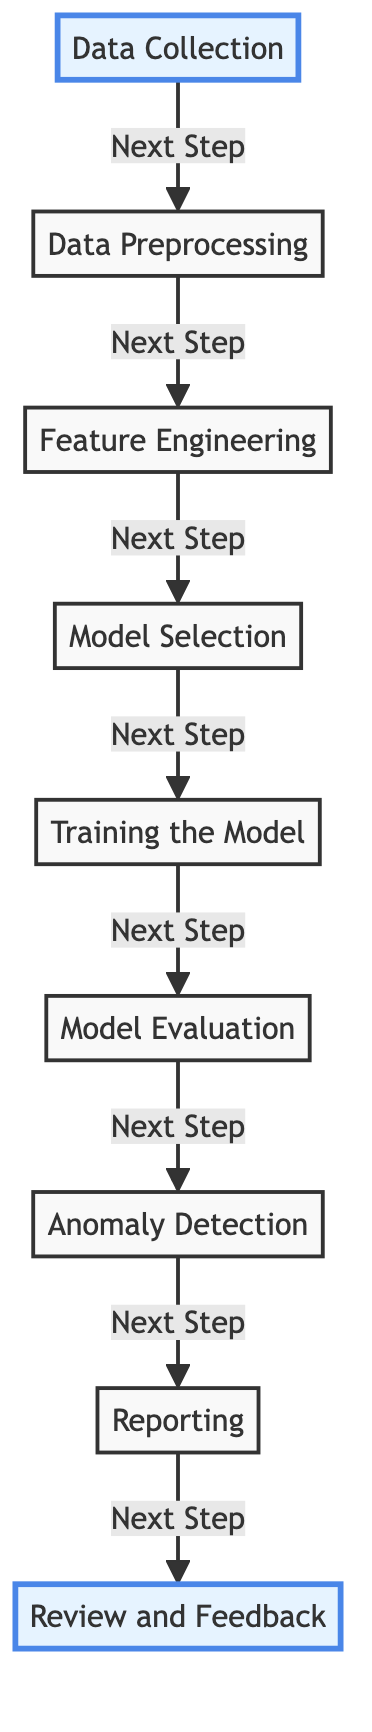What is the first step in the diagram? The first step is "Data Collection," which is indicated as the first node in the flowchart.
Answer: Data Collection How many nodes are present in the diagram? The diagram contains nine nodes, as seen in the flow of steps from data collection to review and feedback.
Answer: Nine What is the last step in the diagram? The last step is "Review and Feedback," which is positioned at the end of the flowchart after reporting the results.
Answer: Review and Feedback Which step comes directly after "Model Evaluation"? "Anomaly Detection" comes directly after "Model Evaluation," as indicated by the subsequent arrow connecting these two steps.
Answer: Anomaly Detection In which step does the machine learning model undergo training? "Training the Model" is the step where the machine learning model is trained, as indicated by its direct placement following model selection.
Answer: Training the Model What is the relationship between "Feature Engineering" and "Model Selection"? "Feature Engineering" is a prerequisite for the "Model Selection," which means it must occur first before selecting the model.
Answer: Prerequisite How many steps are there between "Data Preprocessing" and "Reporting"? There are four steps between "Data Preprocessing" and "Reporting," which are "Feature Engineering," "Model Selection," "Training the Model," and "Model Evaluation."
Answer: Four What type of flow is represented in the diagram? The diagram represents a linear flow, as each step leads sequentially to the next without any branches or cycles.
Answer: Linear flow How does "Data Collection" connect to "Data Preprocessing"? "Data Collection" connects to "Data Preprocessing" directly through an arrow, indicating that it leads directly to this next step.
Answer: Direct connection 